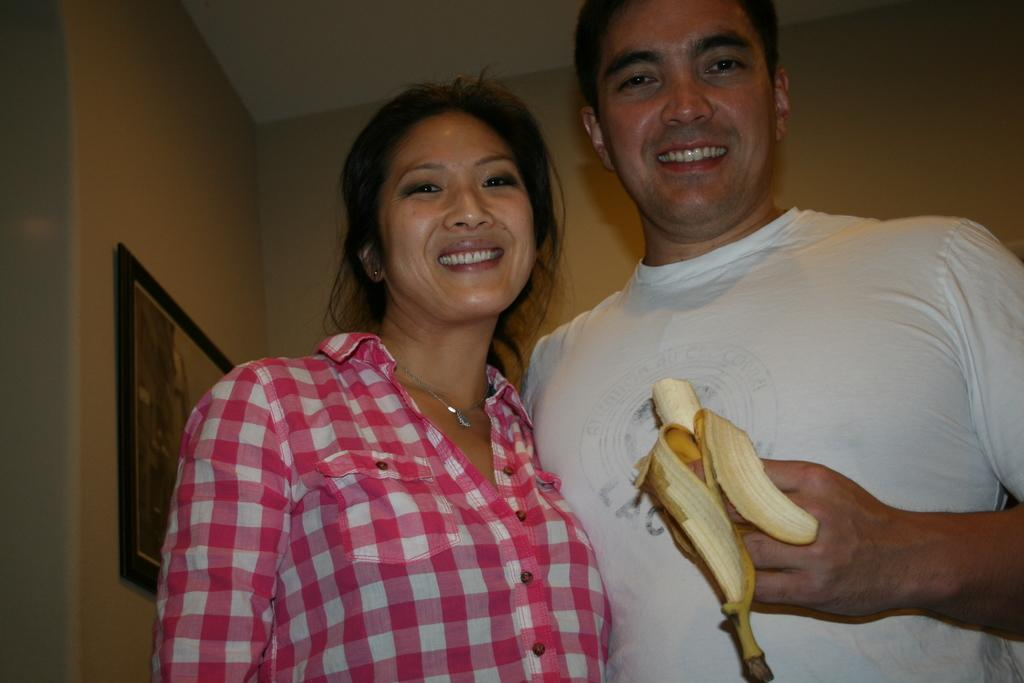How many people are in the image? There are two persons in the image. What is the man holding in the image? The man is holding a banana. What can be seen on the wall in the background? There is a frame on the wall in the background. What is visible at the top of the image? There is a roof visible at the top of the image. What type of wine is being served in the image? There is no wine present in the image; it features two persons and a man holding a banana. What kind of music can be heard playing in the background of the image? There is no music present in the image; it only shows two persons and a man holding a banana. 